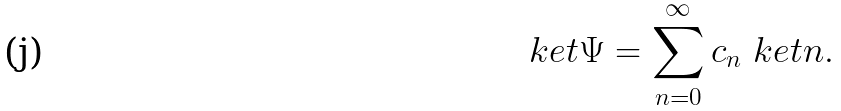Convert formula to latex. <formula><loc_0><loc_0><loc_500><loc_500>\ k e t { \Psi } = \sum _ { n = 0 } ^ { \infty } c _ { n } \ k e t { n } .</formula> 